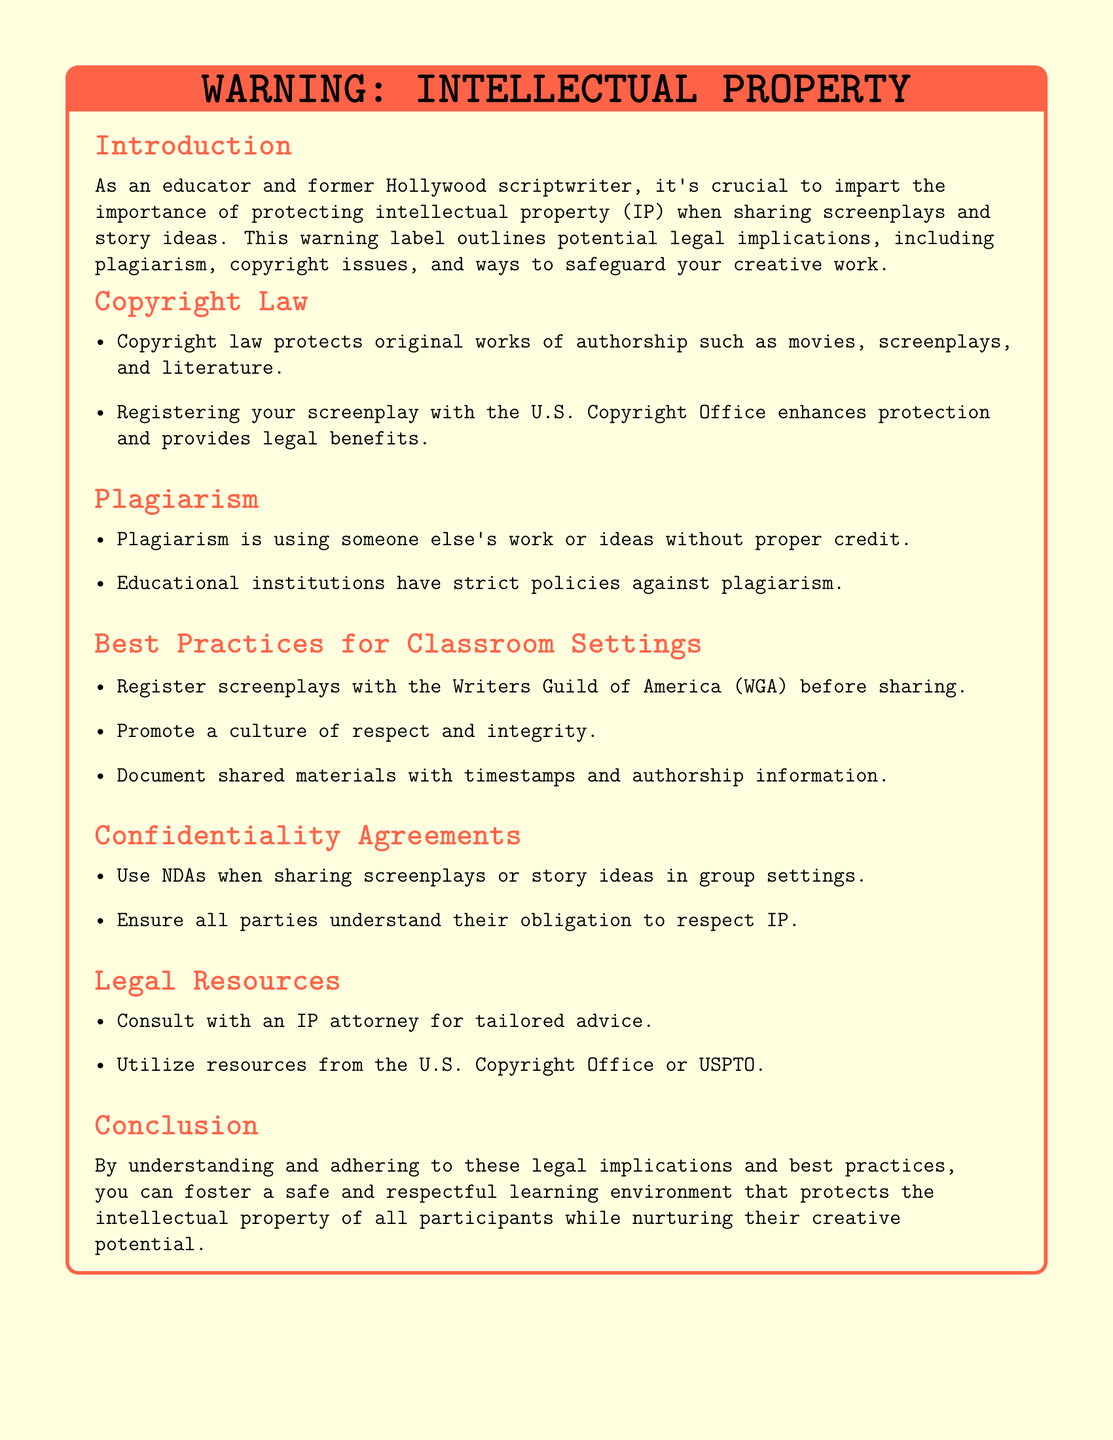What is the title of this document? The title of the document is clearly stated at the beginning of the warning label section.
Answer: WARNING: INTELLECTUAL PROPERTY What does copyright law protect? The document mentions what copyright law protects in the context of original works.
Answer: original works of authorship What organization can writers register their screenplays with? The document specifies an organization for writers to register their screenplays which enhances protection.
Answer: Writers Guild of America (WGA) What is plagiarism defined as in the document? The document gives a definition of plagiarism in the context of using someone else's work.
Answer: using someone else's work or ideas without proper credit What should participants use when sharing screenplays in group settings? The document advises on a specific agreement to be used when sharing screenplays.
Answer: NDAs What is a recommended action before sharing a screenplay? The document suggests a preventive measure to enhance protection before sharing.
Answer: Register screenplays with the WGA What is a potential consequence of not adhering to copyright law in the classroom? The document implies consequences related to educational institutions' policies.
Answer: strict policies against plagiarism Who should you consult for tailored advice on IP? The document mentions a professional resource for advice on intellectual property.
Answer: IP attorney What is the primary focus of the conclusion section? The conclusion summarizes the emphasis placed on understanding and adhering to certain practices.
Answer: protect the intellectual property of all participants 